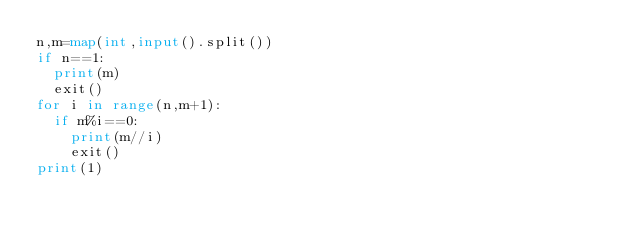<code> <loc_0><loc_0><loc_500><loc_500><_Python_>n,m=map(int,input().split())
if n==1:
  print(m)
  exit()
for i in range(n,m+1):
  if m%i==0:
    print(m//i)
    exit()
print(1)</code> 